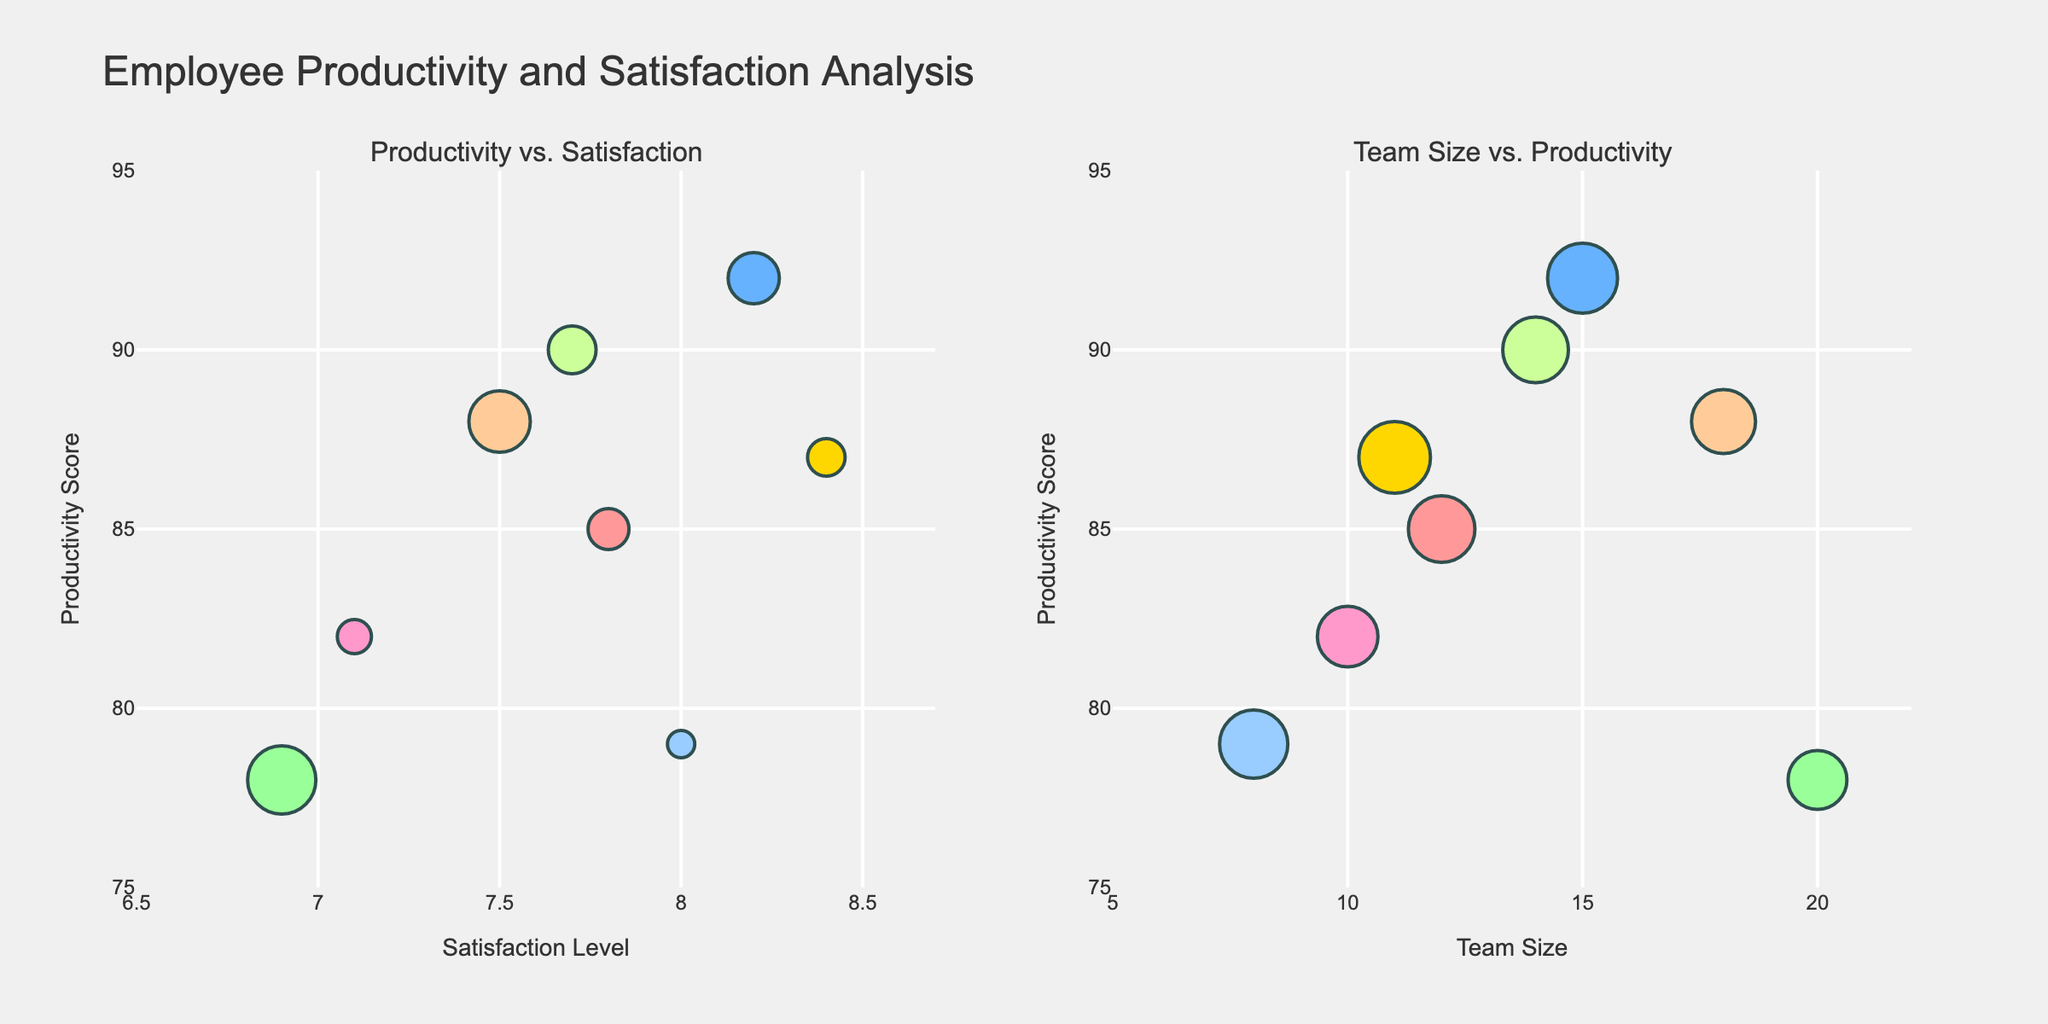What is the title of the figure? The title is located at the top center of the figure. It gives a summary of what the figure represents.
Answer: Employee Productivity vs Maintenance Hours What are the departments being tracked for productivity rates? Look at the legend in the top portion of the figure; it lists the departments that are tracked.
Answer: Engineering, Sales, Customer Service, IT Which month had the lowest maintenance hours? Refer to the second subplot that shows maintenance hours. The shortest bar indicates the lowest maintenance hours.
Answer: November 2023 Which department shows the highest productivity rate in May 2023? In the first subplot, locate May 2023 on the x-axis and compare the heights of the lines representing the departments.
Answer: Sales How many months had maintenance hours greater than or equal to 40 hours? Count the bars in the second subplot whose height is at 40 or higher.
Answer: 7 In which month did both Engineering and IT departments have a productivity rate of exactly 85? Check the first subplot where both Engineering and IT lines intersect; find the corresponding month on the x-axis.
Answer: January 2022 Between Jan 2022 and Dec 2023, how many times did the maintenance hours fall below 20 hours? Refer to the second subplot and count the bars below the 20-hour mark.
Answer: 2 Which department shows the most improvement in productivity rate from Jan 2022 to Dec 2023? Compare the productivity rates in Jan 2022 and Dec 2023 for each department using the first subplot. Calculate the differences and determine which is the largest.
Answer: Sales How does the productivity trend of Customer Service compare to IT? Observe the lines for both Customer Service and IT in the first subplot; note any changes and compare the slopes and values over time.
Answer: Customer Service shows a generally higher productivity rate than IT throughout the period During which month in 2023 did all departments, except Engineering, reach their peak productivity? Trace the lines for each department in the first subplot and find their highest points in 2023, excluding Engineering.
Answer: November 2023 